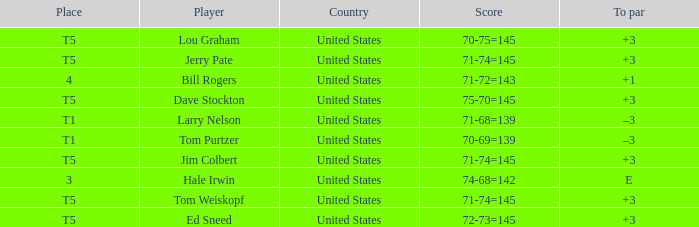What is the to par of player tom weiskopf, who has a 71-74=145 score? 3.0. 